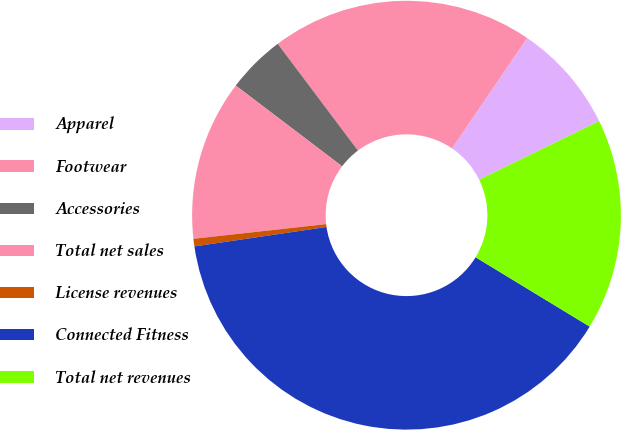<chart> <loc_0><loc_0><loc_500><loc_500><pie_chart><fcel>Apparel<fcel>Footwear<fcel>Accessories<fcel>Total net sales<fcel>License revenues<fcel>Connected Fitness<fcel>Total net revenues<nl><fcel>8.25%<fcel>19.77%<fcel>4.41%<fcel>12.09%<fcel>0.57%<fcel>38.98%<fcel>15.93%<nl></chart> 